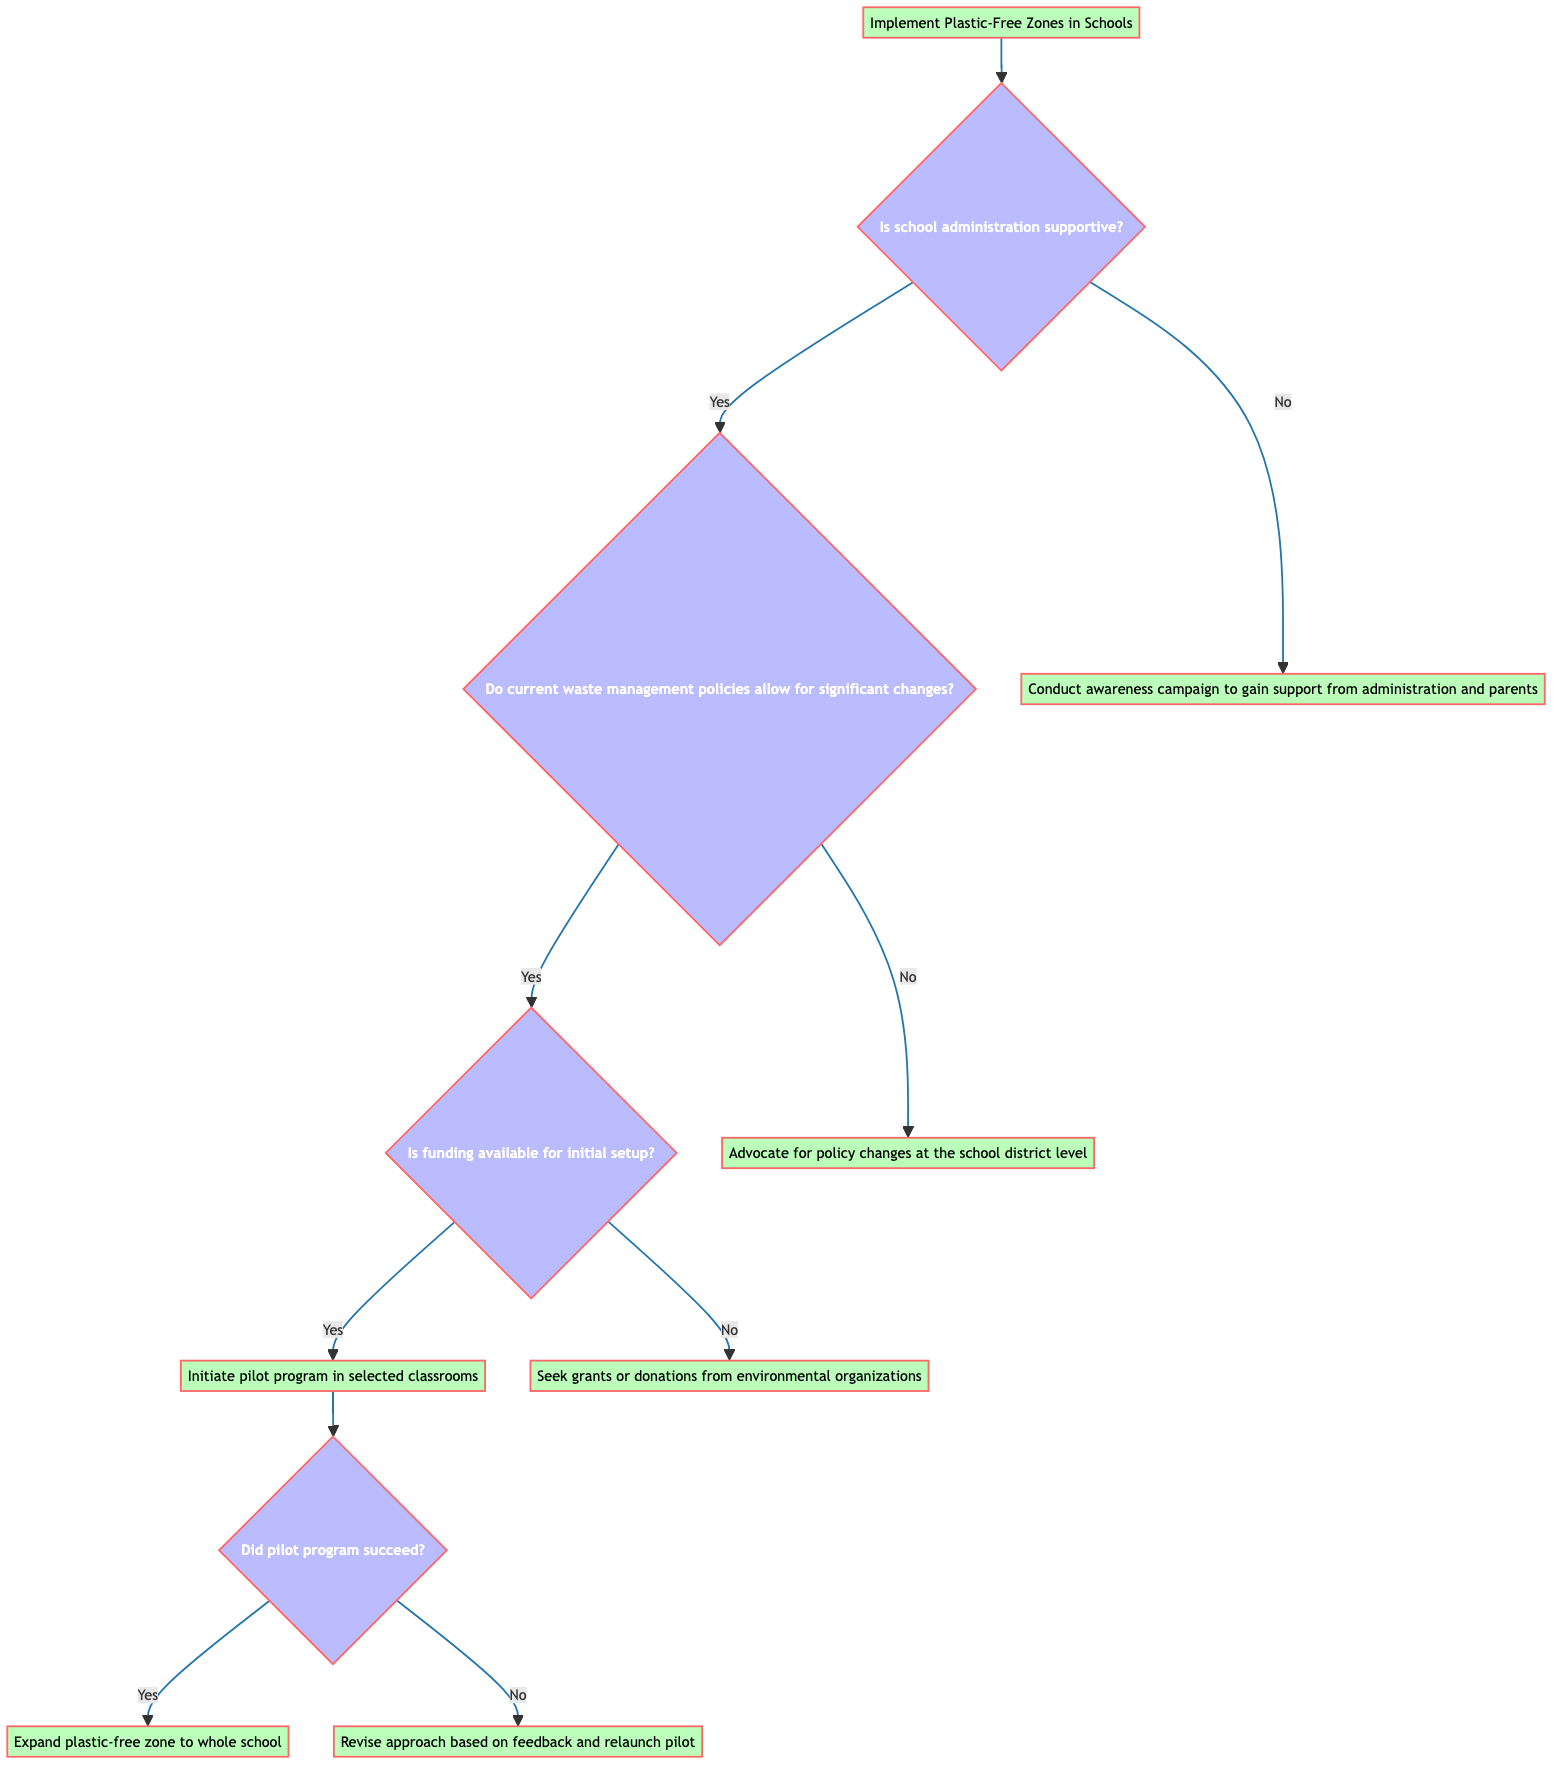What is the first decision point in the diagram? The first decision point in the diagram is whether the school administration is supportive. This is represented as the first question branching from the main decision node.
Answer: Is the school administration supportive? How many total action steps are present in the diagram? To find the total action steps, we can count all terminal nodes (actions) in the diagram. There are five action nodes: Conduct awareness campaign, Advocate for policy changes, Seek grants or donations, Initiate pilot program, and Revise approach.
Answer: Five What action is taken if funding is not available for initial setup? If funding is not available for initial setup, the action taken is to seek grants or donations from environmental organizations. This can be found branching from the funding decision node when answering 'No'.
Answer: Seek grants or donations from environmental organizations If the pilot program succeeds, what is the next action taken? If the pilot program is successful, the next action is to expand the plastic-free zone to the whole school. This is indicated in the diagram following the success of the pilot program.
Answer: Expand plastic-free zone to whole school When the school administration is not supportive, what is the first step recommended? The first step recommended when the school administration is not supportive is to conduct an awareness campaign to gain support from administration and parents. This is directly after the administration's support question in the diagram.
Answer: Conduct awareness campaign to gain support from administration and parents What happens if the current waste management policies do not allow significant changes? If current waste management policies do not allow for significant changes, the action is to advocate for policy changes at the school district level. This shows the relationship between the waste management policies decision and its subsequent action step.
Answer: Advocate for policy changes at the school district level How do we determine if the pilot program succeeded? To determine if the pilot program succeeded, the diagram illustrates a decision node that asks the question: "Did pilot program succeed?" This decision leads to different actions based on a 'Yes' or 'No' response.
Answer: Is the pilot program successful? 